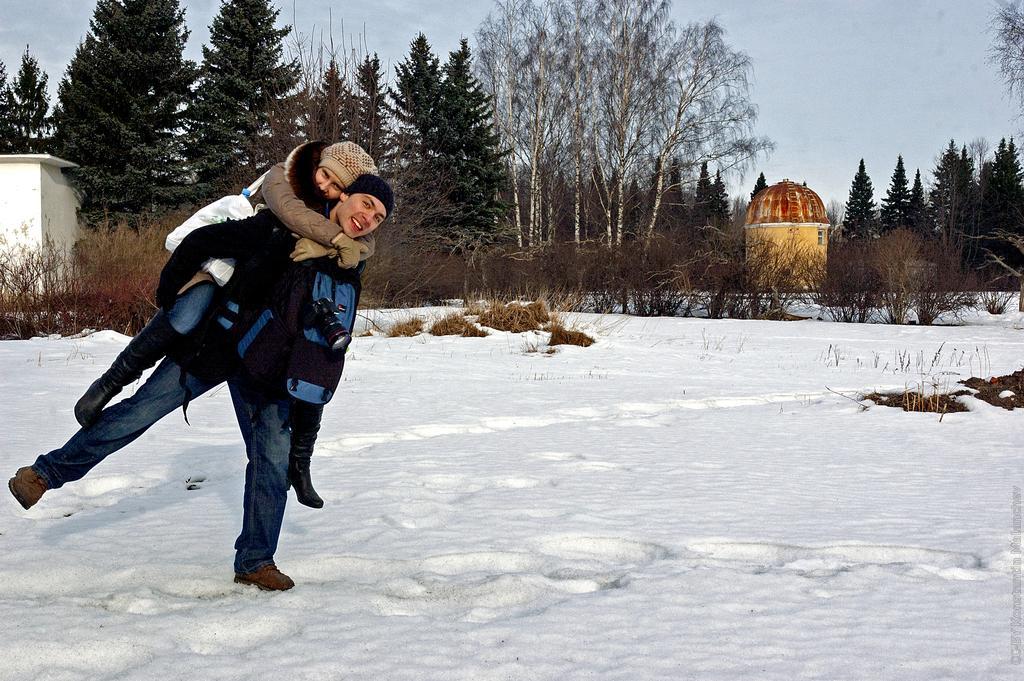Please provide a concise description of this image. In this image I can see two persons, ground full of snow, bushes, number of trees, the sky and few buildings. Here I can see these two are wearing jackets, caps and both of them are carrying bags. I can also see a camera over here. 